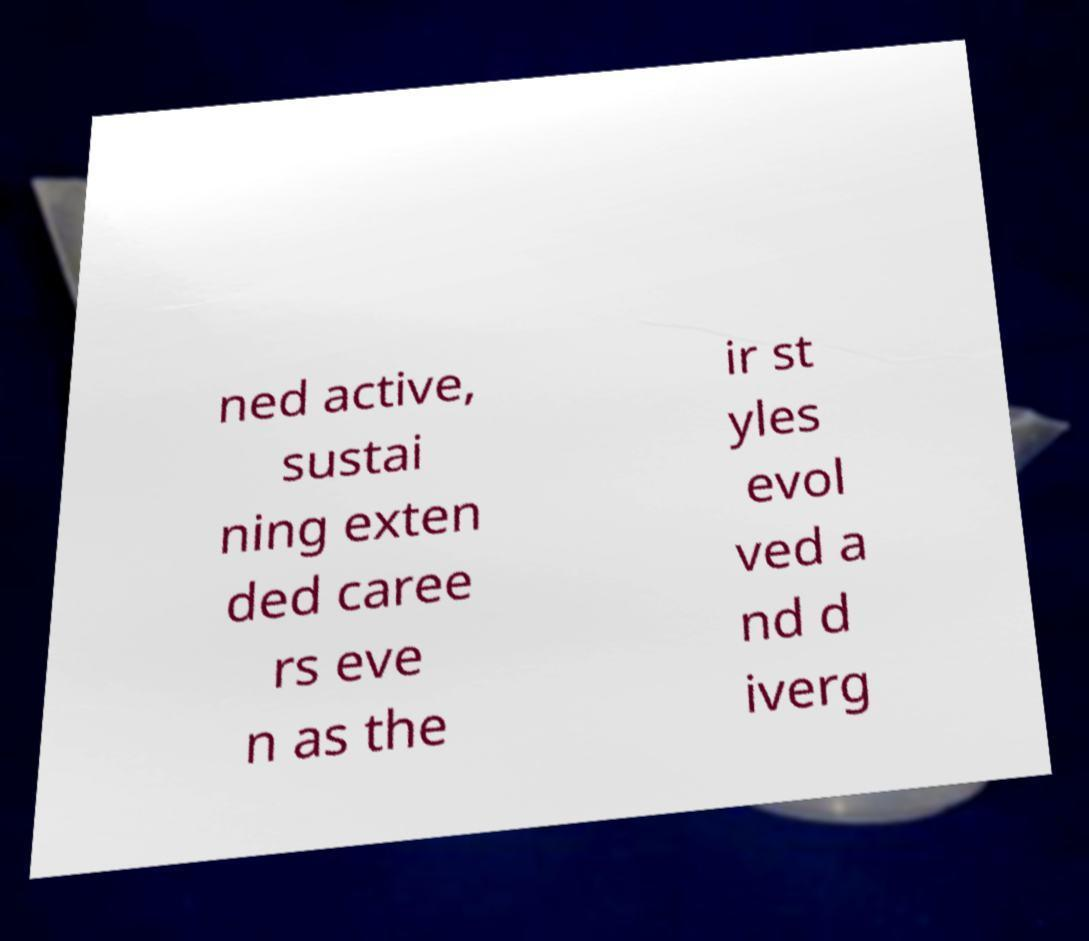Could you assist in decoding the text presented in this image and type it out clearly? ned active, sustai ning exten ded caree rs eve n as the ir st yles evol ved a nd d iverg 